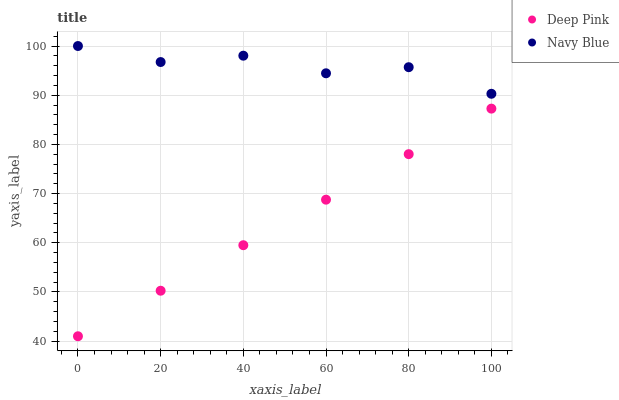Does Deep Pink have the minimum area under the curve?
Answer yes or no. Yes. Does Navy Blue have the maximum area under the curve?
Answer yes or no. Yes. Does Deep Pink have the maximum area under the curve?
Answer yes or no. No. Is Deep Pink the smoothest?
Answer yes or no. Yes. Is Navy Blue the roughest?
Answer yes or no. Yes. Is Deep Pink the roughest?
Answer yes or no. No. Does Deep Pink have the lowest value?
Answer yes or no. Yes. Does Navy Blue have the highest value?
Answer yes or no. Yes. Does Deep Pink have the highest value?
Answer yes or no. No. Is Deep Pink less than Navy Blue?
Answer yes or no. Yes. Is Navy Blue greater than Deep Pink?
Answer yes or no. Yes. Does Deep Pink intersect Navy Blue?
Answer yes or no. No. 